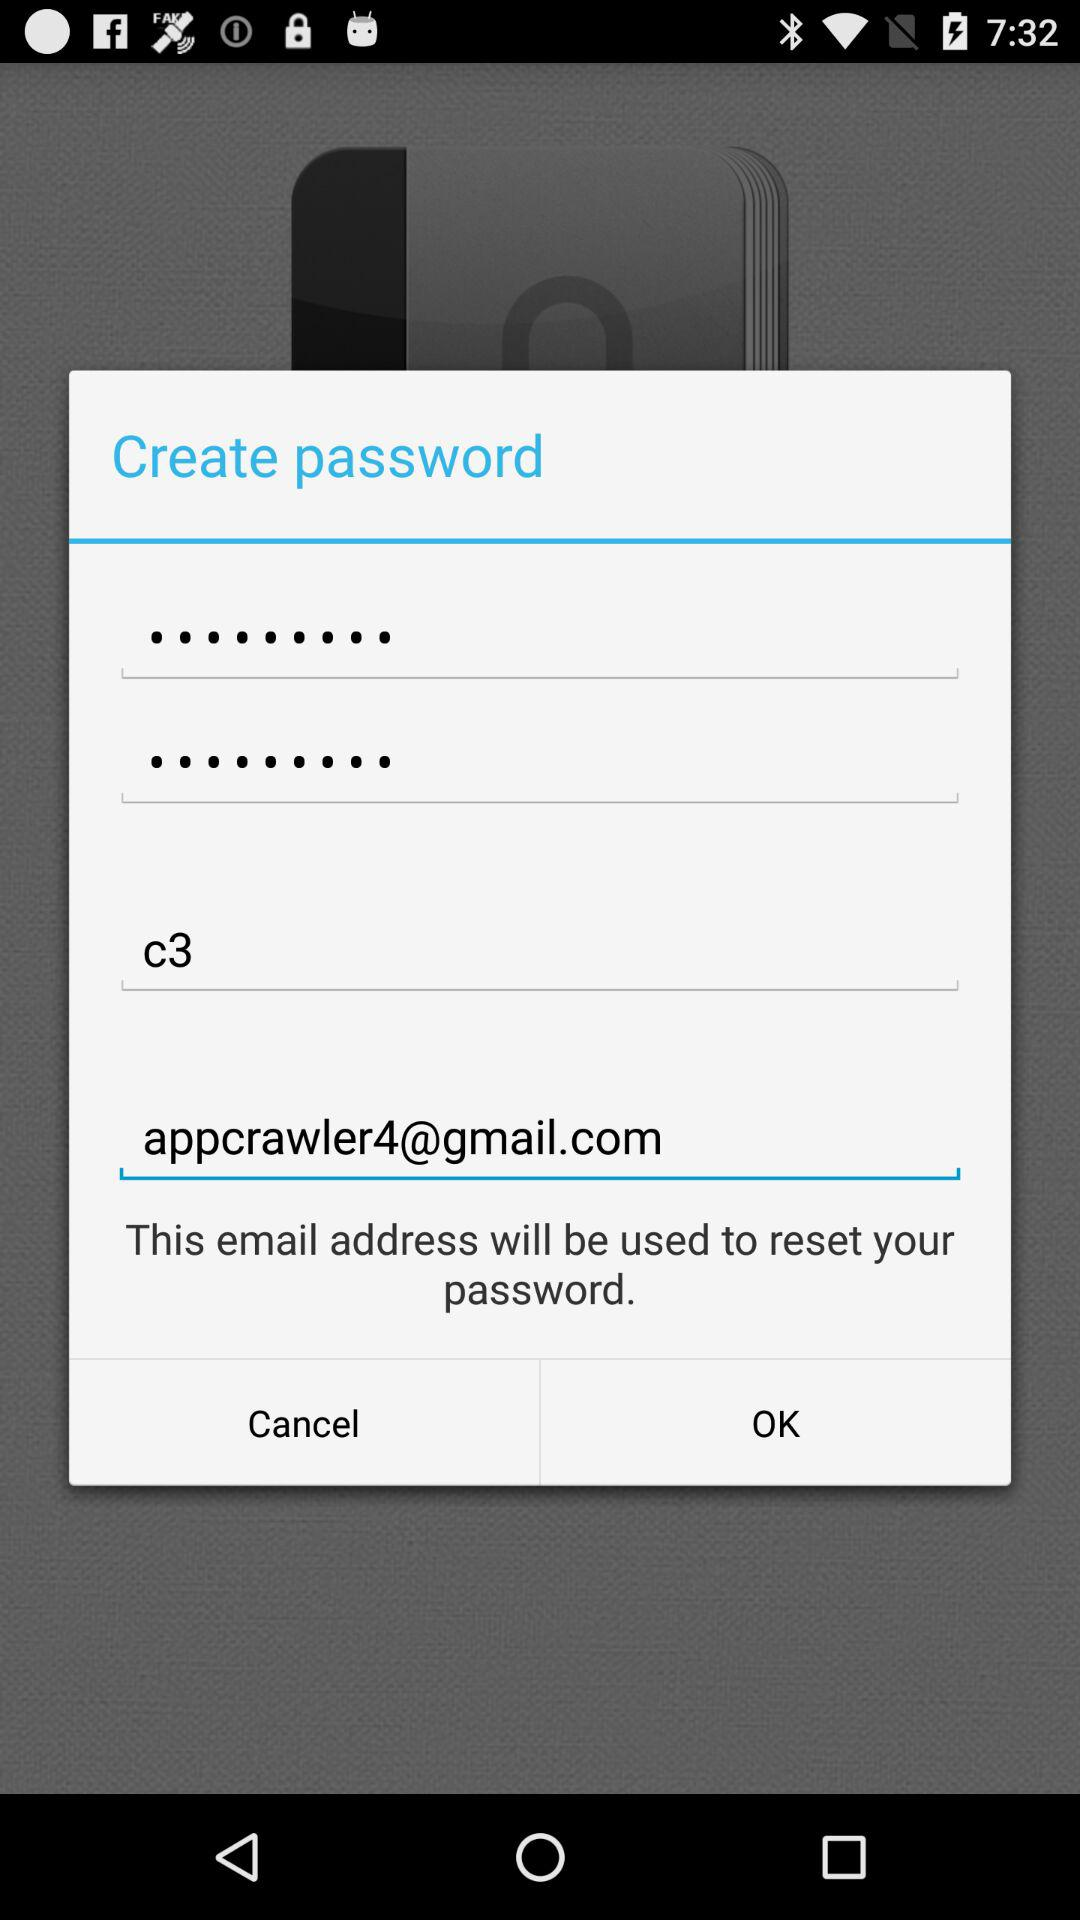What is the email address? The email address is appcrawler4@gmail.com. 